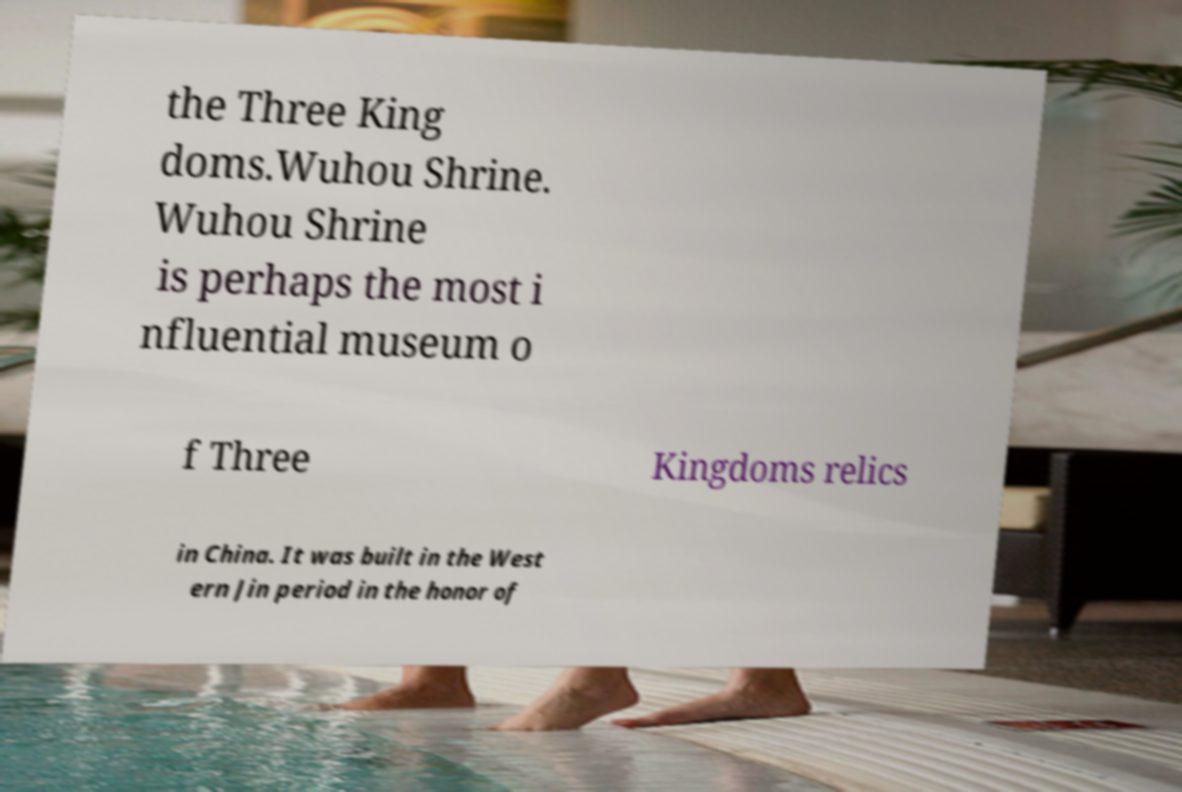Could you assist in decoding the text presented in this image and type it out clearly? the Three King doms.Wuhou Shrine. Wuhou Shrine is perhaps the most i nfluential museum o f Three Kingdoms relics in China. It was built in the West ern Jin period in the honor of 